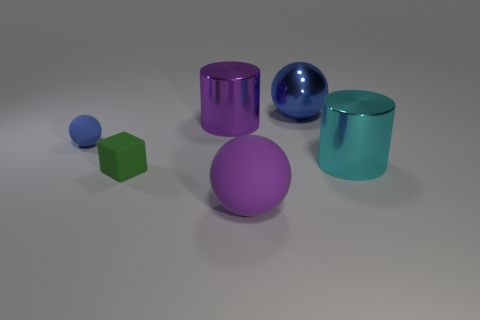Add 1 small blue rubber things. How many objects exist? 7 Subtract all cylinders. How many objects are left? 4 Add 4 cyan things. How many cyan things are left? 5 Add 2 tiny cyan rubber spheres. How many tiny cyan rubber spheres exist? 2 Subtract 0 red balls. How many objects are left? 6 Subtract all small green rubber blocks. Subtract all small rubber objects. How many objects are left? 3 